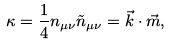Convert formula to latex. <formula><loc_0><loc_0><loc_500><loc_500>\kappa = \frac { 1 } { 4 } n _ { \mu \nu } \tilde { n } _ { \mu \nu } = \vec { k } \cdot \vec { m } ,</formula> 